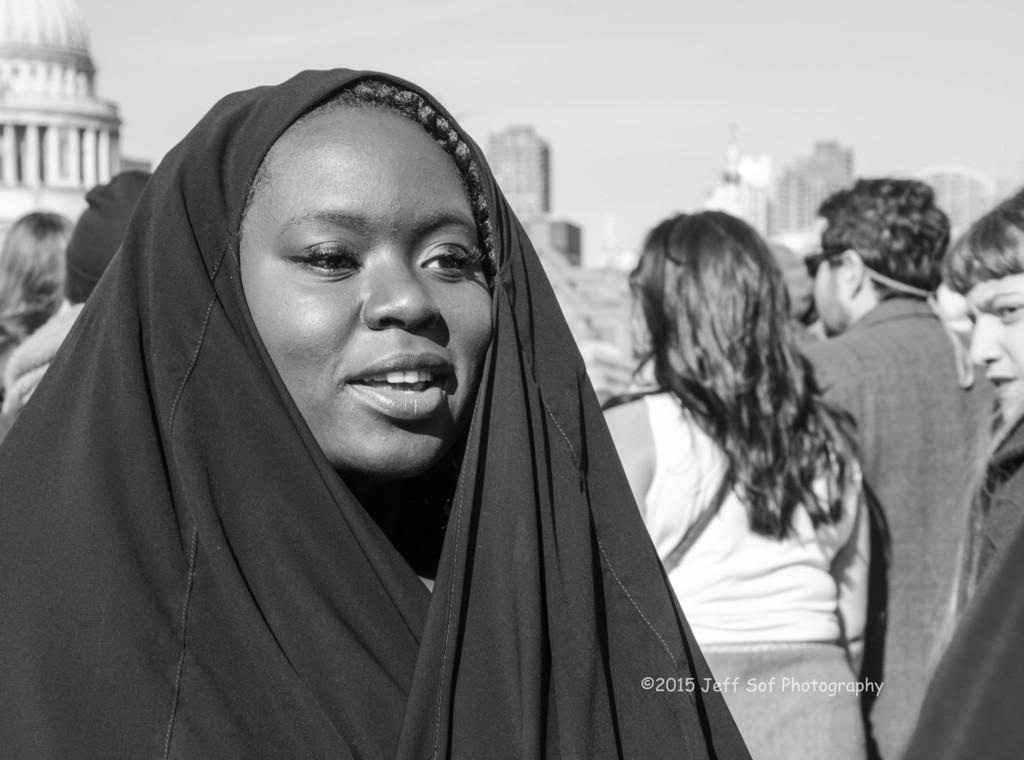Could you give a brief overview of what you see in this image? This is a black and white picture, there is a woman with cloth over her head standing on the left side and behind there are many people walking, on the background there are buildings and above its sky. 